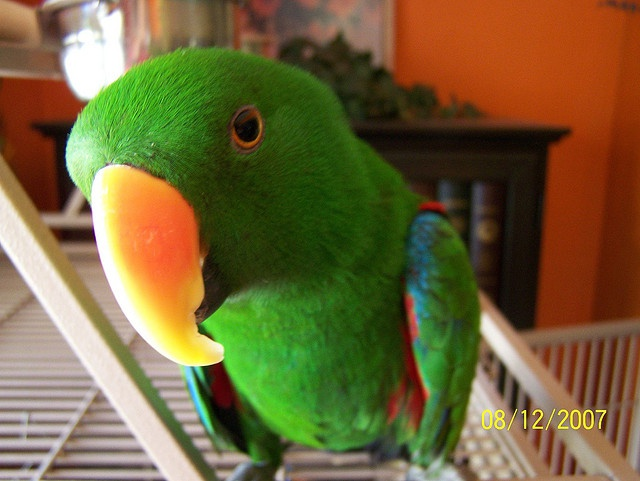Describe the objects in this image and their specific colors. I can see bird in tan, darkgreen, and green tones, potted plant in tan, black, maroon, and brown tones, book in tan, black, gray, and maroon tones, and book in tan, black, maroon, and gray tones in this image. 